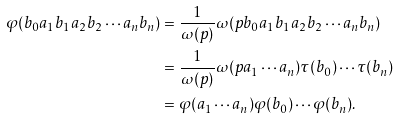<formula> <loc_0><loc_0><loc_500><loc_500>\varphi ( b _ { 0 } a _ { 1 } b _ { 1 } a _ { 2 } b _ { 2 } \cdots a _ { n } b _ { n } ) & = \frac { 1 } { \omega ( p ) } \omega ( p b _ { 0 } a _ { 1 } b _ { 1 } a _ { 2 } b _ { 2 } \cdots a _ { n } b _ { n } ) \\ & = \frac { 1 } { \omega ( p ) } \omega ( p a _ { 1 } \cdots a _ { n } ) \tau ( b _ { 0 } ) \cdots \tau ( b _ { n } ) \\ & = \varphi ( a _ { 1 } \cdots a _ { n } ) \varphi ( b _ { 0 } ) \cdots \varphi ( b _ { n } ) .</formula> 